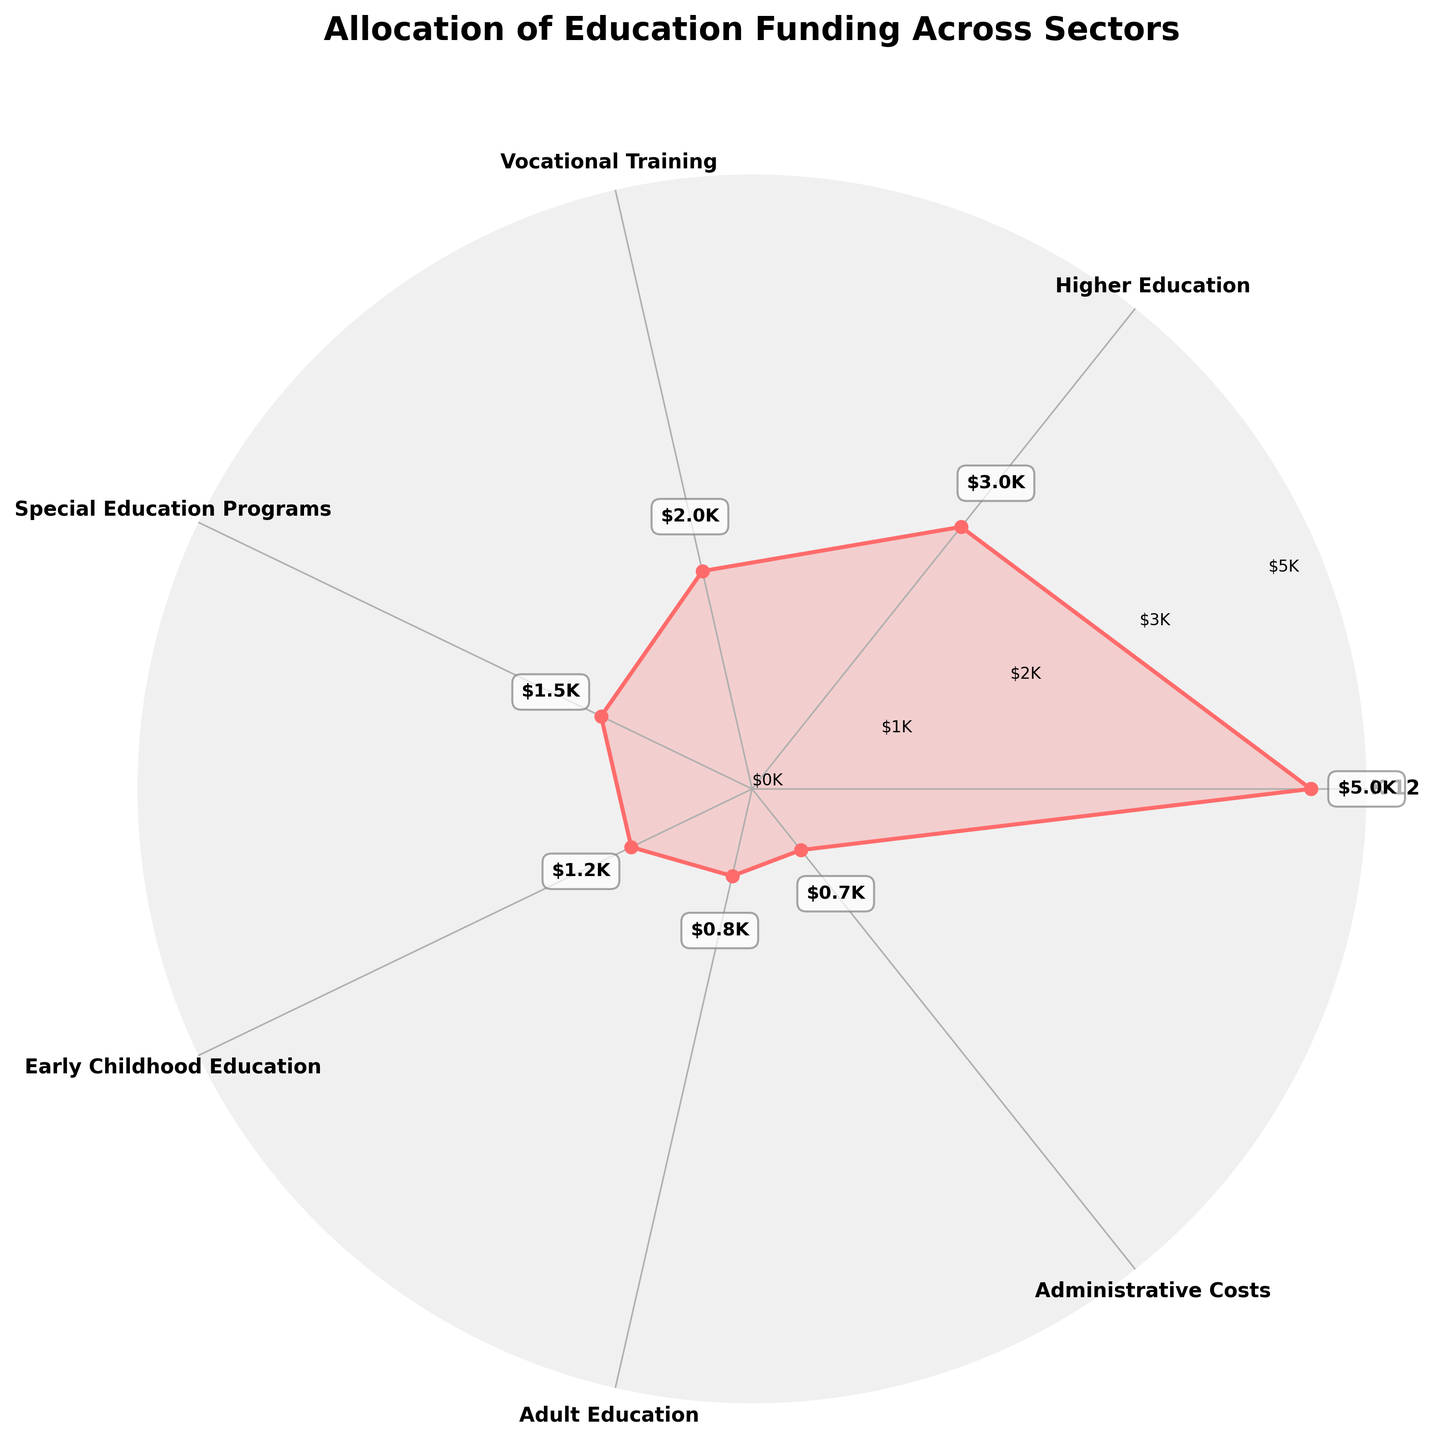What is the title of the figure? The title of the figure is usually displayed at the top of the chart. Here, it clearly states "Allocation of Education Funding Across Sectors".
Answer: Allocation of Education Funding Across Sectors Which sector has the highest funding allocation? By looking at the plot, the length of the radial line corresponding to each sector indicates their funding amounts. The longest line corresponds to K-12, indicating it has the highest funding allocation.
Answer: K-12 Approximately how much funding is allocated to Early Childhood Education? Observing the radial line for the Early Childhood Education sector, the funding amount can be seen at the end of the line. It is close to $1200.
Answer: $1200 Compare the funding for Higher Education and Vocational Training. Which sector receives more? By comparing the radial lines for Higher Education and Vocational Training, it is clear that the line for Higher Education is longer, indicating more funding.
Answer: Higher Education How many funding sectors are shown in the figure? Counting the number of distinct radial lines and sectors listed around the circle gives us the total sectors represented in the figure.
Answer: 7 What is the total allocation for all sectors shown? The total allocation is calculated by summing up all the funding amounts: $5000 (K-12) + $3000 (Higher Education) + $2000 (Vocational Training) + $1500 (Special Education Programs) + $1200 (Early Childhood Education) + $800 (Adult Education) + $700 (Administrative Costs) = $14200.
Answer: $14200 How does the funding for Special Education Programs compare to Adult Education? By looking at the radial lengths, it's clear that Special Education Programs have been allocated more than Adult Education. Quantitatively, Special Education Programs have $1500 while Adult Education has $800.
Answer: Special Education Programs receives more funding What percentage of the total funding is allocated to Vocational Training? First, calculate the total funding: $14200. Then, use the Vocational Training amount $2000. The percentage is calculated as (2000/14200) * 100 = approximately 14.08%.
Answer: ~14.08% What is the combined allocation for Early Childhood Education and Adult Education? Adding the amounts for Early Childhood Education ($1200) and Adult Education ($800) yields $1200 + $800 = $2000.
Answer: $2000 Describe the color used for the data representation in the chart. The chart uses a plot color that resembles a shade of red (specifically '#FF6B6B'). The fill color within the plotted area has a lower opacity of the same red shade.
Answer: Shade of red 